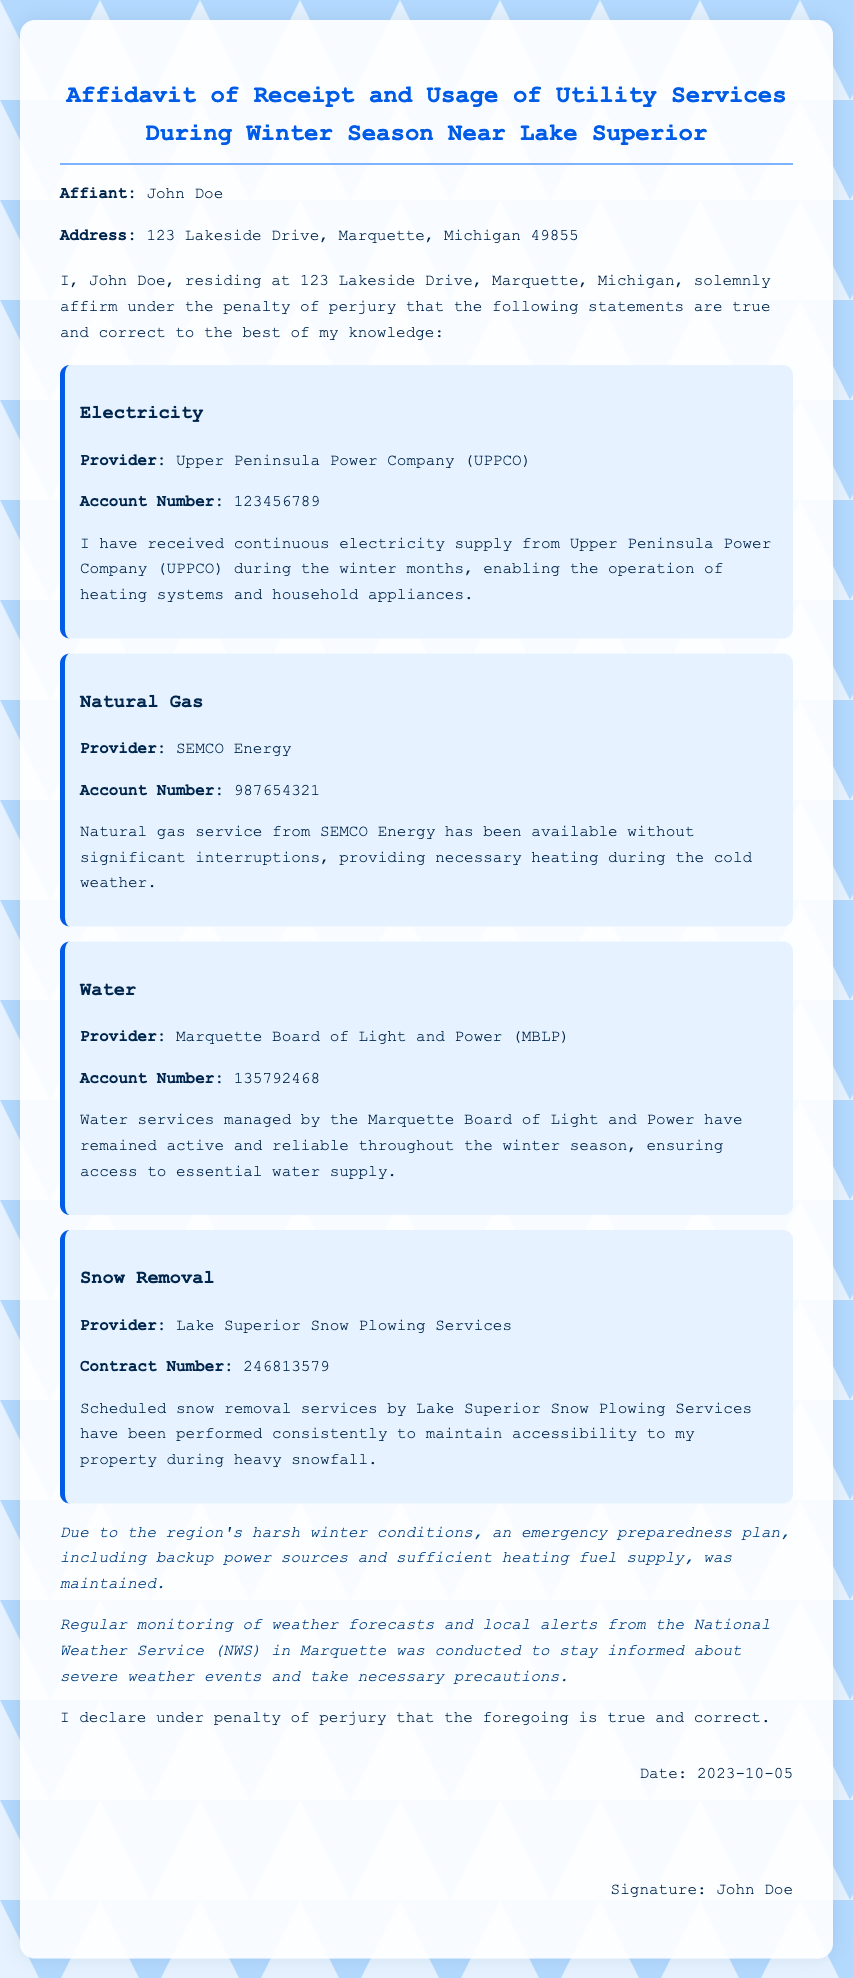What is the name of the affiant? The name of the affiant is stated at the beginning of the document.
Answer: John Doe What is the address of the affiant? The address is provided right after the name of the affiant.
Answer: 123 Lakeside Drive, Marquette, Michigan 49855 Who is the provider of electricity? The provider of electricity is mentioned under the electricity section of the utility services.
Answer: Upper Peninsula Power Company (UPPCO) What service does SEMCO Energy provide? SEMCO Energy is specifically identified in the document under the natural gas section.
Answer: Natural gas What is the date of the affidavit? The date appears in the signature area at the bottom of the document.
Answer: 2023-10-05 Which service includes scheduled snow removal? This service is detailed in the snow removal section of the utility services.
Answer: Lake Superior Snow Plowing Services What statement does John Doe make regarding the accuracy of the document? This statement is found in the final part of the document before the signature.
Answer: I declare under penalty of perjury that the foregoing is true and correct What emergency preparedness measures were maintained? This information is highlighted in the weather notes section of the document.
Answer: Backup power sources and sufficient heating fuel supply What type of document is this? This type of document is specified in the title at the top of the document.
Answer: Affidavit of Receipt and Usage of Utility Services During Winter Season Near Lake Superior 